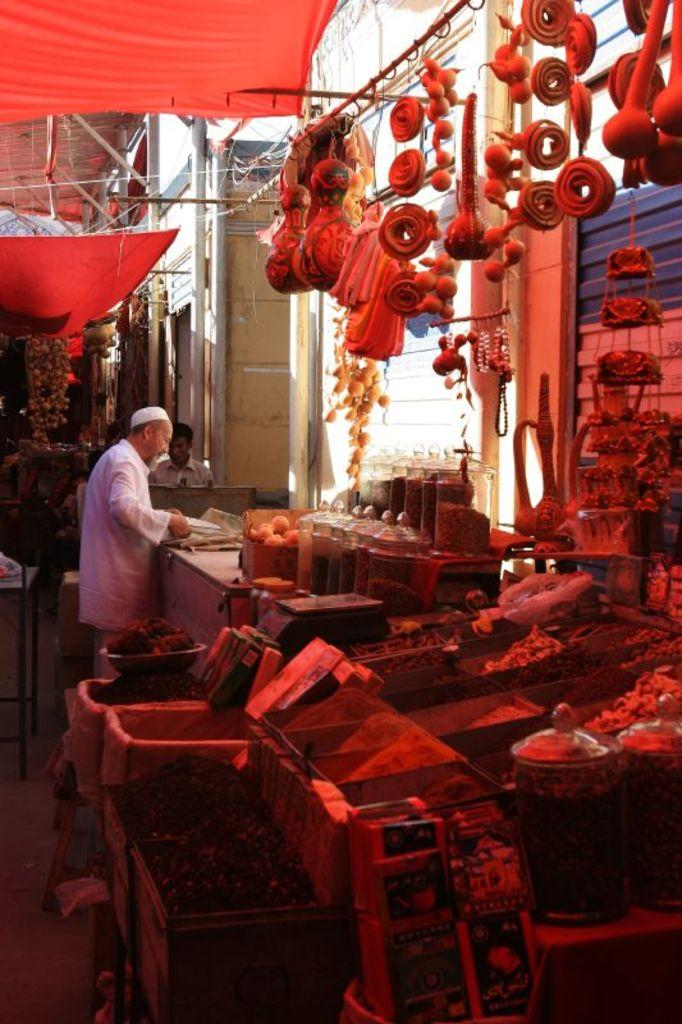What is the main subject in the foreground of the image? There is a shop of different food in the foreground of the image. What can be seen in the background of the image? There are people in the background of the image. What type of structures are visible at the top of the image? There are tents visible at the top of the image. What type of lace is used to decorate the volleyball in the image? There is no volleyball present in the image, so it is not possible to determine what type of lace might be used to decorate it. 